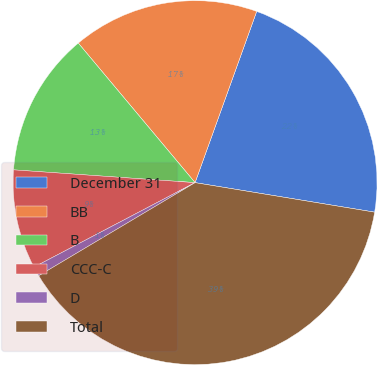Convert chart. <chart><loc_0><loc_0><loc_500><loc_500><pie_chart><fcel>December 31<fcel>BB<fcel>B<fcel>CCC-C<fcel>D<fcel>Total<nl><fcel>22.1%<fcel>16.59%<fcel>12.79%<fcel>8.81%<fcel>0.86%<fcel>38.86%<nl></chart> 